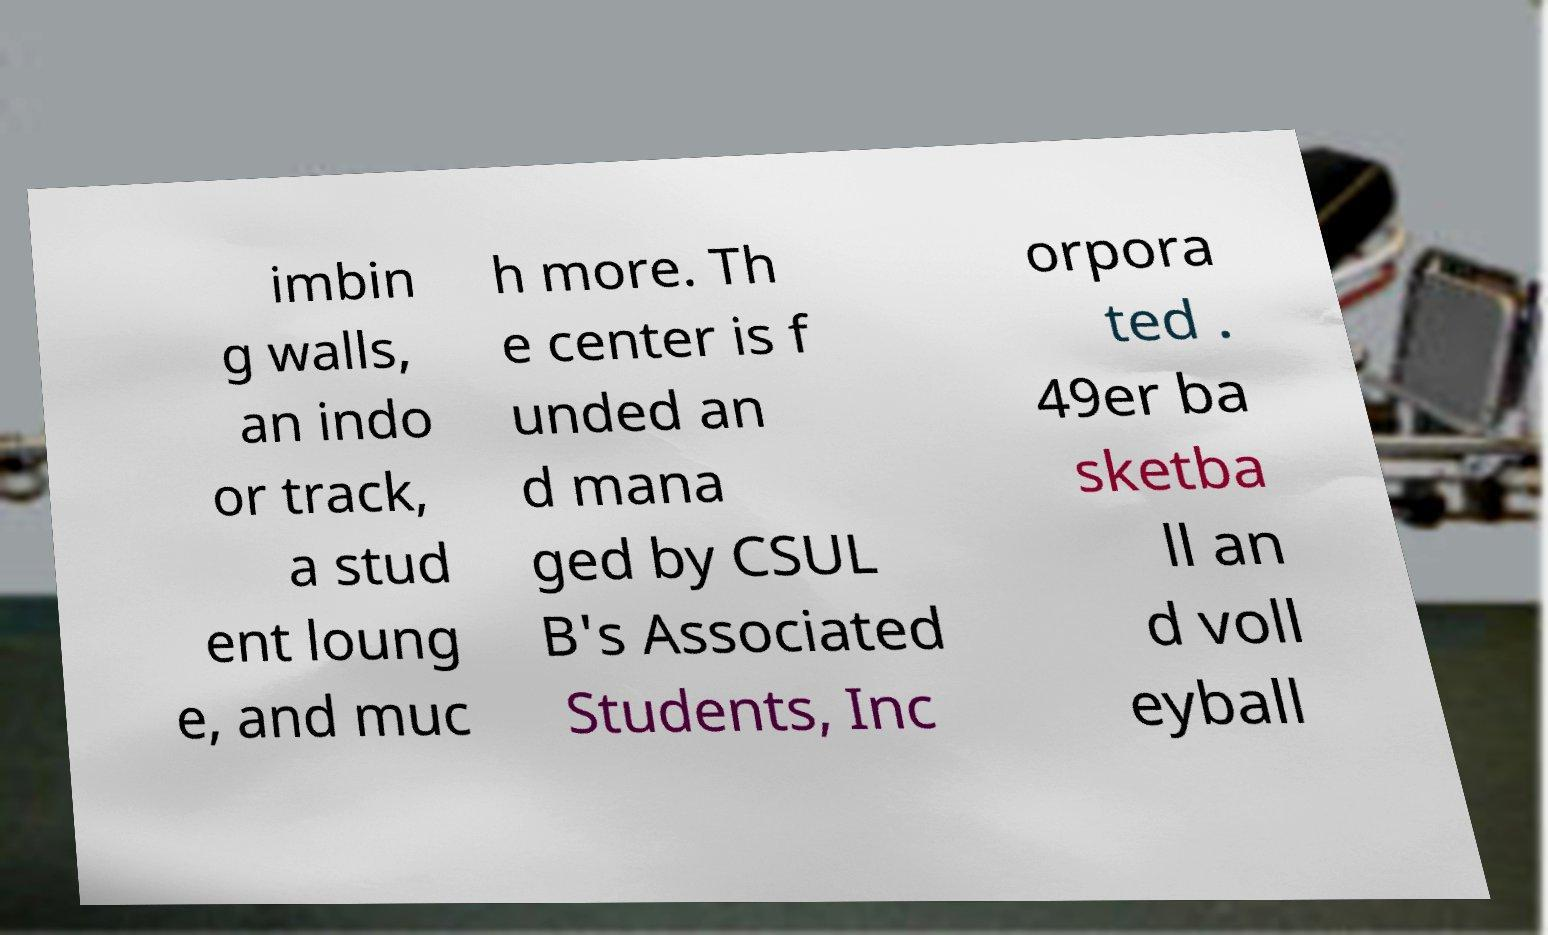Could you assist in decoding the text presented in this image and type it out clearly? imbin g walls, an indo or track, a stud ent loung e, and muc h more. Th e center is f unded an d mana ged by CSUL B's Associated Students, Inc orpora ted . 49er ba sketba ll an d voll eyball 